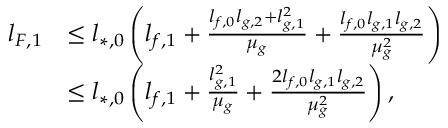Convert formula to latex. <formula><loc_0><loc_0><loc_500><loc_500>\begin{array} { r l } { l _ { F , 1 } } & { \leq l _ { * , 0 } \left ( l _ { f , 1 } + \frac { l _ { f , 0 } l _ { g , 2 } + l _ { g , 1 } ^ { 2 } } { \mu _ { g } } + \frac { l _ { f , 0 } l _ { g , 1 } l _ { g , 2 } } { \mu _ { g } ^ { 2 } } \right ) } \\ & { \leq l _ { * , 0 } \left ( l _ { f , 1 } + \frac { l _ { g , 1 } ^ { 2 } } { \mu _ { g } } + \frac { 2 l _ { f , 0 } l _ { g , 1 } l _ { g , 2 } } { \mu _ { g } ^ { 2 } } \right ) , } \end{array}</formula> 